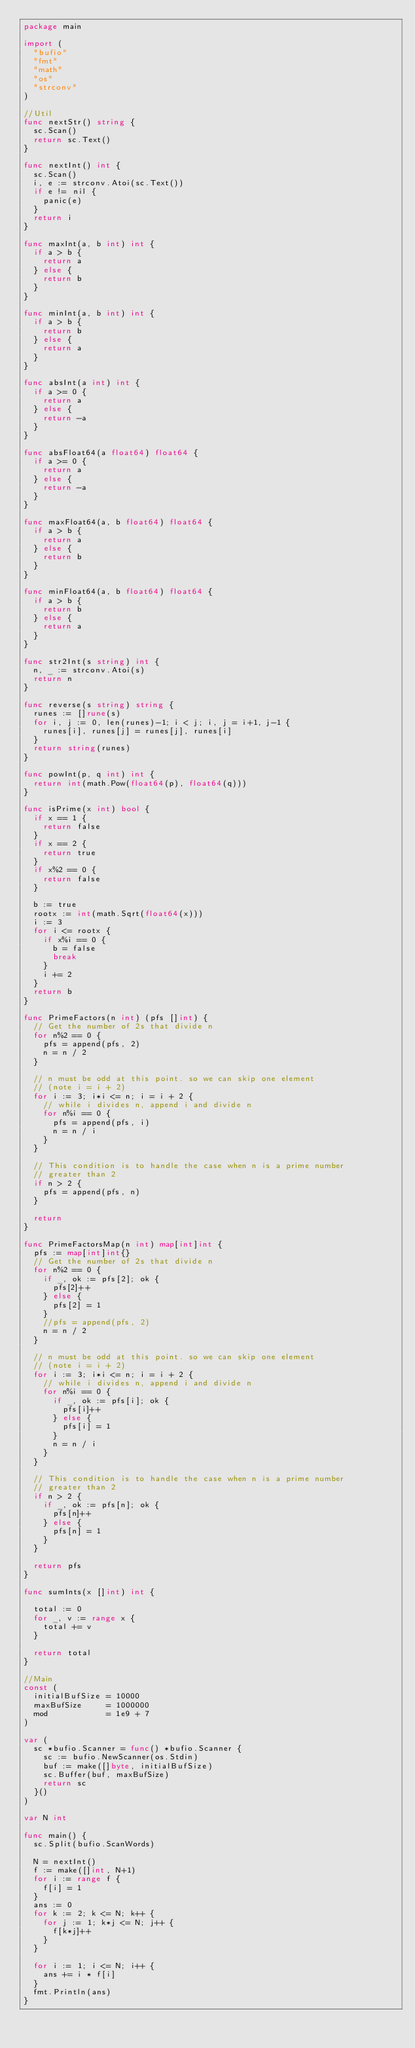Convert code to text. <code><loc_0><loc_0><loc_500><loc_500><_Go_>package main

import (
	"bufio"
	"fmt"
	"math"
	"os"
	"strconv"
)

//Util
func nextStr() string {
	sc.Scan()
	return sc.Text()
}

func nextInt() int {
	sc.Scan()
	i, e := strconv.Atoi(sc.Text())
	if e != nil {
		panic(e)
	}
	return i
}

func maxInt(a, b int) int {
	if a > b {
		return a
	} else {
		return b
	}
}

func minInt(a, b int) int {
	if a > b {
		return b
	} else {
		return a
	}
}

func absInt(a int) int {
	if a >= 0 {
		return a
	} else {
		return -a
	}
}

func absFloat64(a float64) float64 {
	if a >= 0 {
		return a
	} else {
		return -a
	}
}

func maxFloat64(a, b float64) float64 {
	if a > b {
		return a
	} else {
		return b
	}
}

func minFloat64(a, b float64) float64 {
	if a > b {
		return b
	} else {
		return a
	}
}

func str2Int(s string) int {
	n, _ := strconv.Atoi(s)
	return n
}

func reverse(s string) string {
	runes := []rune(s)
	for i, j := 0, len(runes)-1; i < j; i, j = i+1, j-1 {
		runes[i], runes[j] = runes[j], runes[i]
	}
	return string(runes)
}

func powInt(p, q int) int {
	return int(math.Pow(float64(p), float64(q)))
}

func isPrime(x int) bool {
	if x == 1 {
		return false
	}
	if x == 2 {
		return true
	}
	if x%2 == 0 {
		return false
	}

	b := true
	rootx := int(math.Sqrt(float64(x)))
	i := 3
	for i <= rootx {
		if x%i == 0 {
			b = false
			break
		}
		i += 2
	}
	return b
}

func PrimeFactors(n int) (pfs []int) {
	// Get the number of 2s that divide n
	for n%2 == 0 {
		pfs = append(pfs, 2)
		n = n / 2
	}

	// n must be odd at this point. so we can skip one element
	// (note i = i + 2)
	for i := 3; i*i <= n; i = i + 2 {
		// while i divides n, append i and divide n
		for n%i == 0 {
			pfs = append(pfs, i)
			n = n / i
		}
	}

	// This condition is to handle the case when n is a prime number
	// greater than 2
	if n > 2 {
		pfs = append(pfs, n)
	}

	return
}

func PrimeFactorsMap(n int) map[int]int {
	pfs := map[int]int{}
	// Get the number of 2s that divide n
	for n%2 == 0 {
		if _, ok := pfs[2]; ok {
			pfs[2]++
		} else {
			pfs[2] = 1
		}
		//pfs = append(pfs, 2)
		n = n / 2
	}

	// n must be odd at this point. so we can skip one element
	// (note i = i + 2)
	for i := 3; i*i <= n; i = i + 2 {
		// while i divides n, append i and divide n
		for n%i == 0 {
			if _, ok := pfs[i]; ok {
				pfs[i]++
			} else {
				pfs[i] = 1
			}
			n = n / i
		}
	}

	// This condition is to handle the case when n is a prime number
	// greater than 2
	if n > 2 {
		if _, ok := pfs[n]; ok {
			pfs[n]++
		} else {
			pfs[n] = 1
		}
	}

	return pfs
}

func sumInts(x []int) int {

	total := 0
	for _, v := range x {
		total += v
	}

	return total
}

//Main
const (
	initialBufSize = 10000
	maxBufSize     = 1000000
	mod            = 1e9 + 7
)

var (
	sc *bufio.Scanner = func() *bufio.Scanner {
		sc := bufio.NewScanner(os.Stdin)
		buf := make([]byte, initialBufSize)
		sc.Buffer(buf, maxBufSize)
		return sc
	}()
)

var N int

func main() {
	sc.Split(bufio.ScanWords)

	N = nextInt()
	f := make([]int, N+1)
	for i := range f {
		f[i] = 1
	}
	ans := 0
	for k := 2; k <= N; k++ {
		for j := 1; k*j <= N; j++ {
			f[k*j]++
		}
	}

	for i := 1; i <= N; i++ {
		ans += i * f[i]
	}
	fmt.Println(ans)
}
</code> 